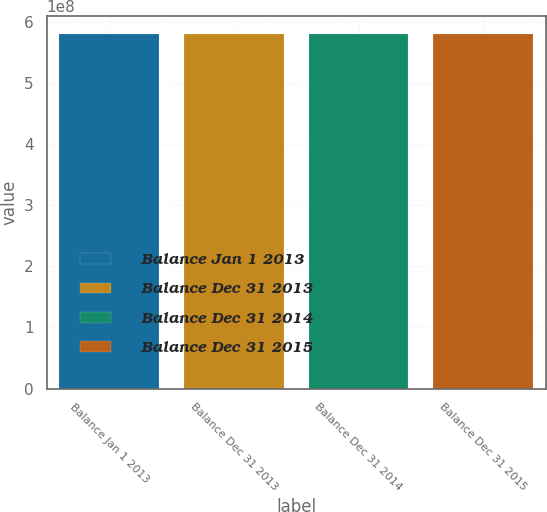<chart> <loc_0><loc_0><loc_500><loc_500><bar_chart><fcel>Balance Jan 1 2013<fcel>Balance Dec 31 2013<fcel>Balance Dec 31 2014<fcel>Balance Dec 31 2015<nl><fcel>5.81146e+08<fcel>5.81146e+08<fcel>5.81146e+08<fcel>5.81146e+08<nl></chart> 